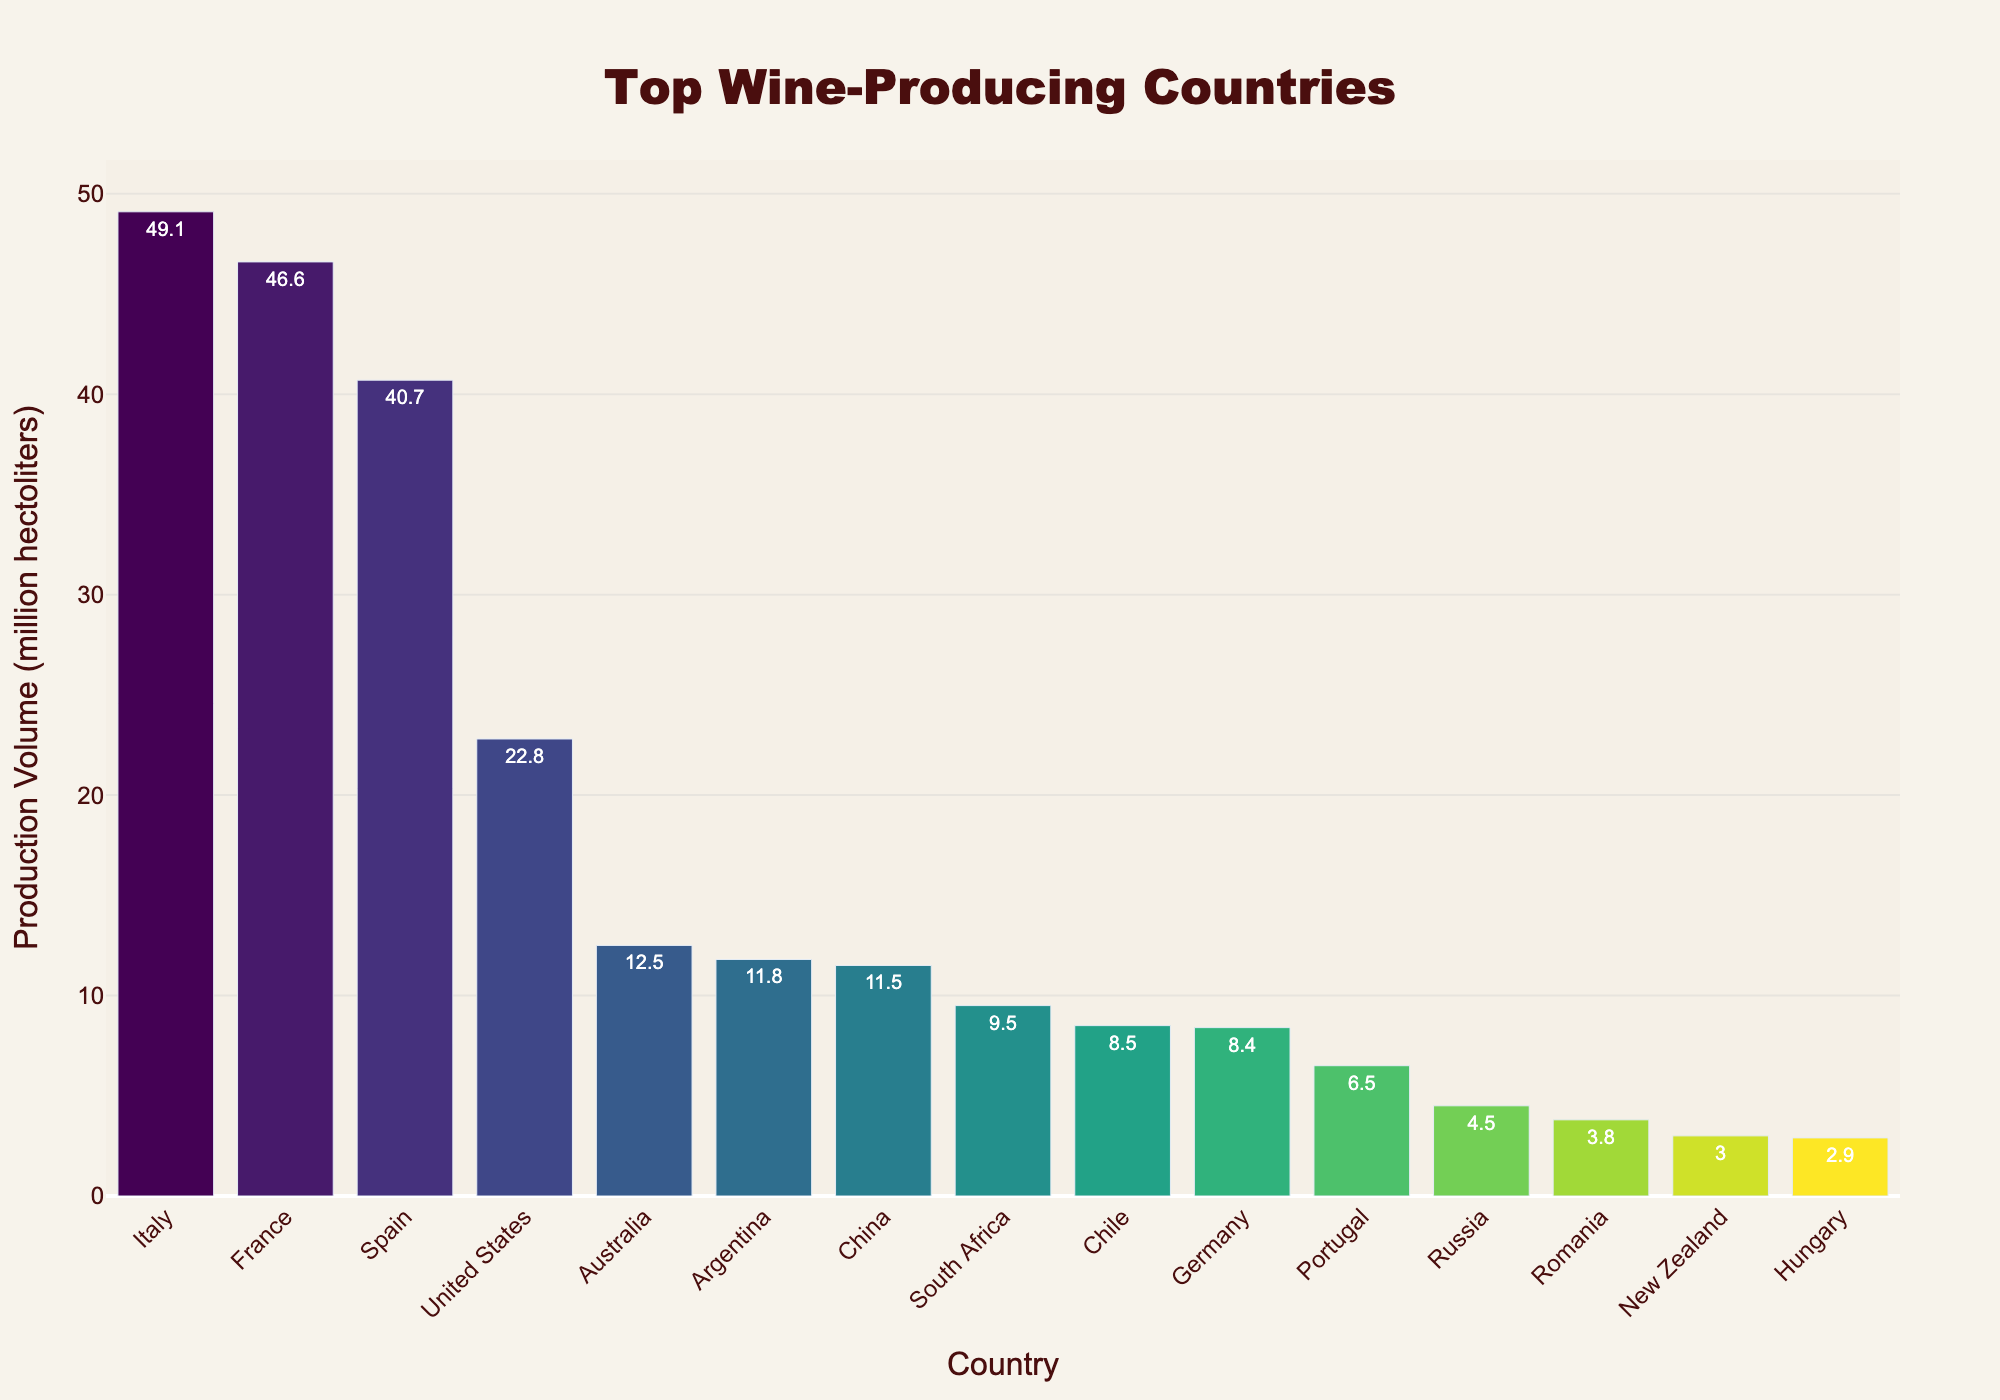What's the production volume of the top wine-producing country? According to the bar chart, Italy is the top wine-producing country, and its production volume is indicated by the height of the bar corresponding to Italy.
Answer: 49.1 million hectoliters Which country is the second-largest wine producer, and what's its production volume? By looking at the second bar in descending order of production volume, we can see that France is the second-largest wine producer with a production volume indicated on the bar.
Answer: France, 46.6 million hectoliters How much more wine does Italy produce compared to the United States? Italy's production volume is 49.1 million hectoliters, and the United States produces 22.8 million hectoliters. The difference is calculated by subtracting the United States' volume from Italy's volume. 49.1 - 22.8 = 26.3 million hectoliters
Answer: 26.3 million hectoliters Which countries produce less than 10 million hectoliters of wine annually? By examining the bars with production volumes indicated at less than 10 million hectoliters, we identify South Africa, Chile, Germany, Portugal, Russia, Romania, New Zealand, and Hungary as the countries producing less than 10 million hectoliters.
Answer: South Africa, Chile, Germany, Portugal, Russia, Romania, New Zealand, Hungary What's the combined production volume of the top three wine-producing countries? Summing the production volumes of the top three countries (Italy, France, and Spain): 49.1 + 46.6 + 40.7 = 136.4 million hectoliters
Answer: 136.4 million hectoliters Which country produces slightly more wine: Argentina or China? By comparing the heights of the bars for Argentina and China, Argentina produces slightly more with a production volume of 11.8 million hectoliters compared to China’s 11.5 million hectoliters.
Answer: Argentina What is the average production volume of the bottom five wine-producing countries listed on the chart? Summing the production volumes of the bottom five countries (Germany, Portugal, Russia, Romania, New Zealand, and Hungary) and dividing by five: (8.4 + 6.5 + 4.5 + 3.8 + 3.0 + 2.9) / 5 = 29.1 / 5 = 5.82 million hectoliters
Answer: 5.82 million hectoliters Which country is placed exactly between Australia and Argentina in terms of production volume? The country visually positioned between the bars of Australia (12.5 million hectoliters) and Argentina (11.8 million hectoliters) is China, with a production volume of 11.5 million hectoliters.
Answer: China How many more million hectoliters does Spain produce compared to Germany? Spain's production volume is 40.7 million hectoliters, and Germany's is 8.4 million hectoliters. The difference is calculated by subtracting Germany's volume from Spain's volume. 40.7 - 8.4 = 32.3 million hectoliters
Answer: 32.3 million hectoliters 